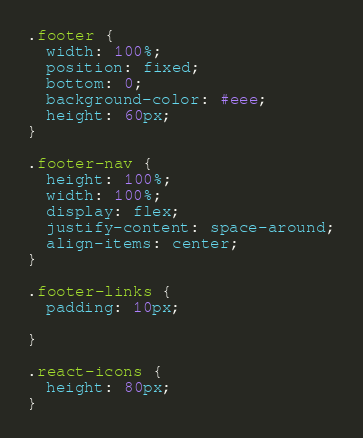<code> <loc_0><loc_0><loc_500><loc_500><_CSS_>.footer {
  width: 100%;
  position: fixed;
  bottom: 0;
  background-color: #eee;
  height: 60px;
}

.footer-nav {
  height: 100%;
  width: 100%;
  display: flex;
  justify-content: space-around;
  align-items: center;
}

.footer-links {
  padding: 10px;
  
}

.react-icons {
  height: 80px;
}</code> 